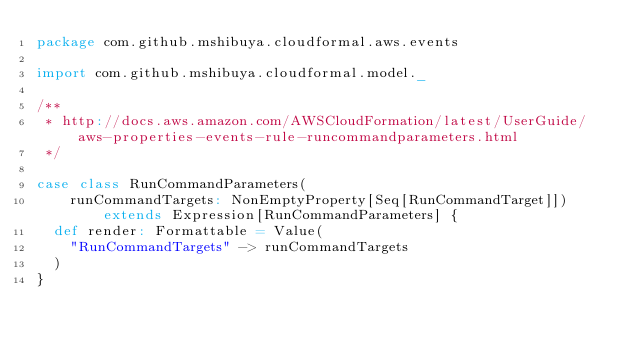Convert code to text. <code><loc_0><loc_0><loc_500><loc_500><_Scala_>package com.github.mshibuya.cloudformal.aws.events

import com.github.mshibuya.cloudformal.model._

/**
 * http://docs.aws.amazon.com/AWSCloudFormation/latest/UserGuide/aws-properties-events-rule-runcommandparameters.html
 */

case class RunCommandParameters(
    runCommandTargets: NonEmptyProperty[Seq[RunCommandTarget]]) extends Expression[RunCommandParameters] {
  def render: Formattable = Value(
    "RunCommandTargets" -> runCommandTargets
  )
}
</code> 